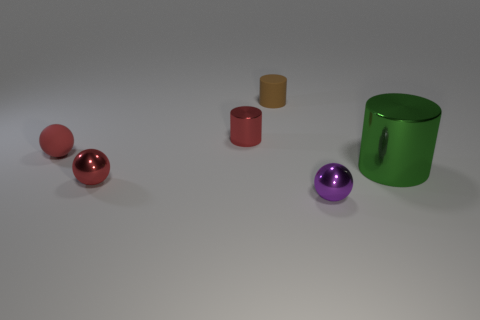What sort of environment or setting could these objects be a part of? These objects, with their simple geometric shapes and clean surfaces, might be a part of a modern art installation or an educational setting for teaching shapes and colors. The arrangement suggests a deliberate placement for either aesthetic viewing or for a demonstration, such as for photography or a physics experiment on light and reflection. 